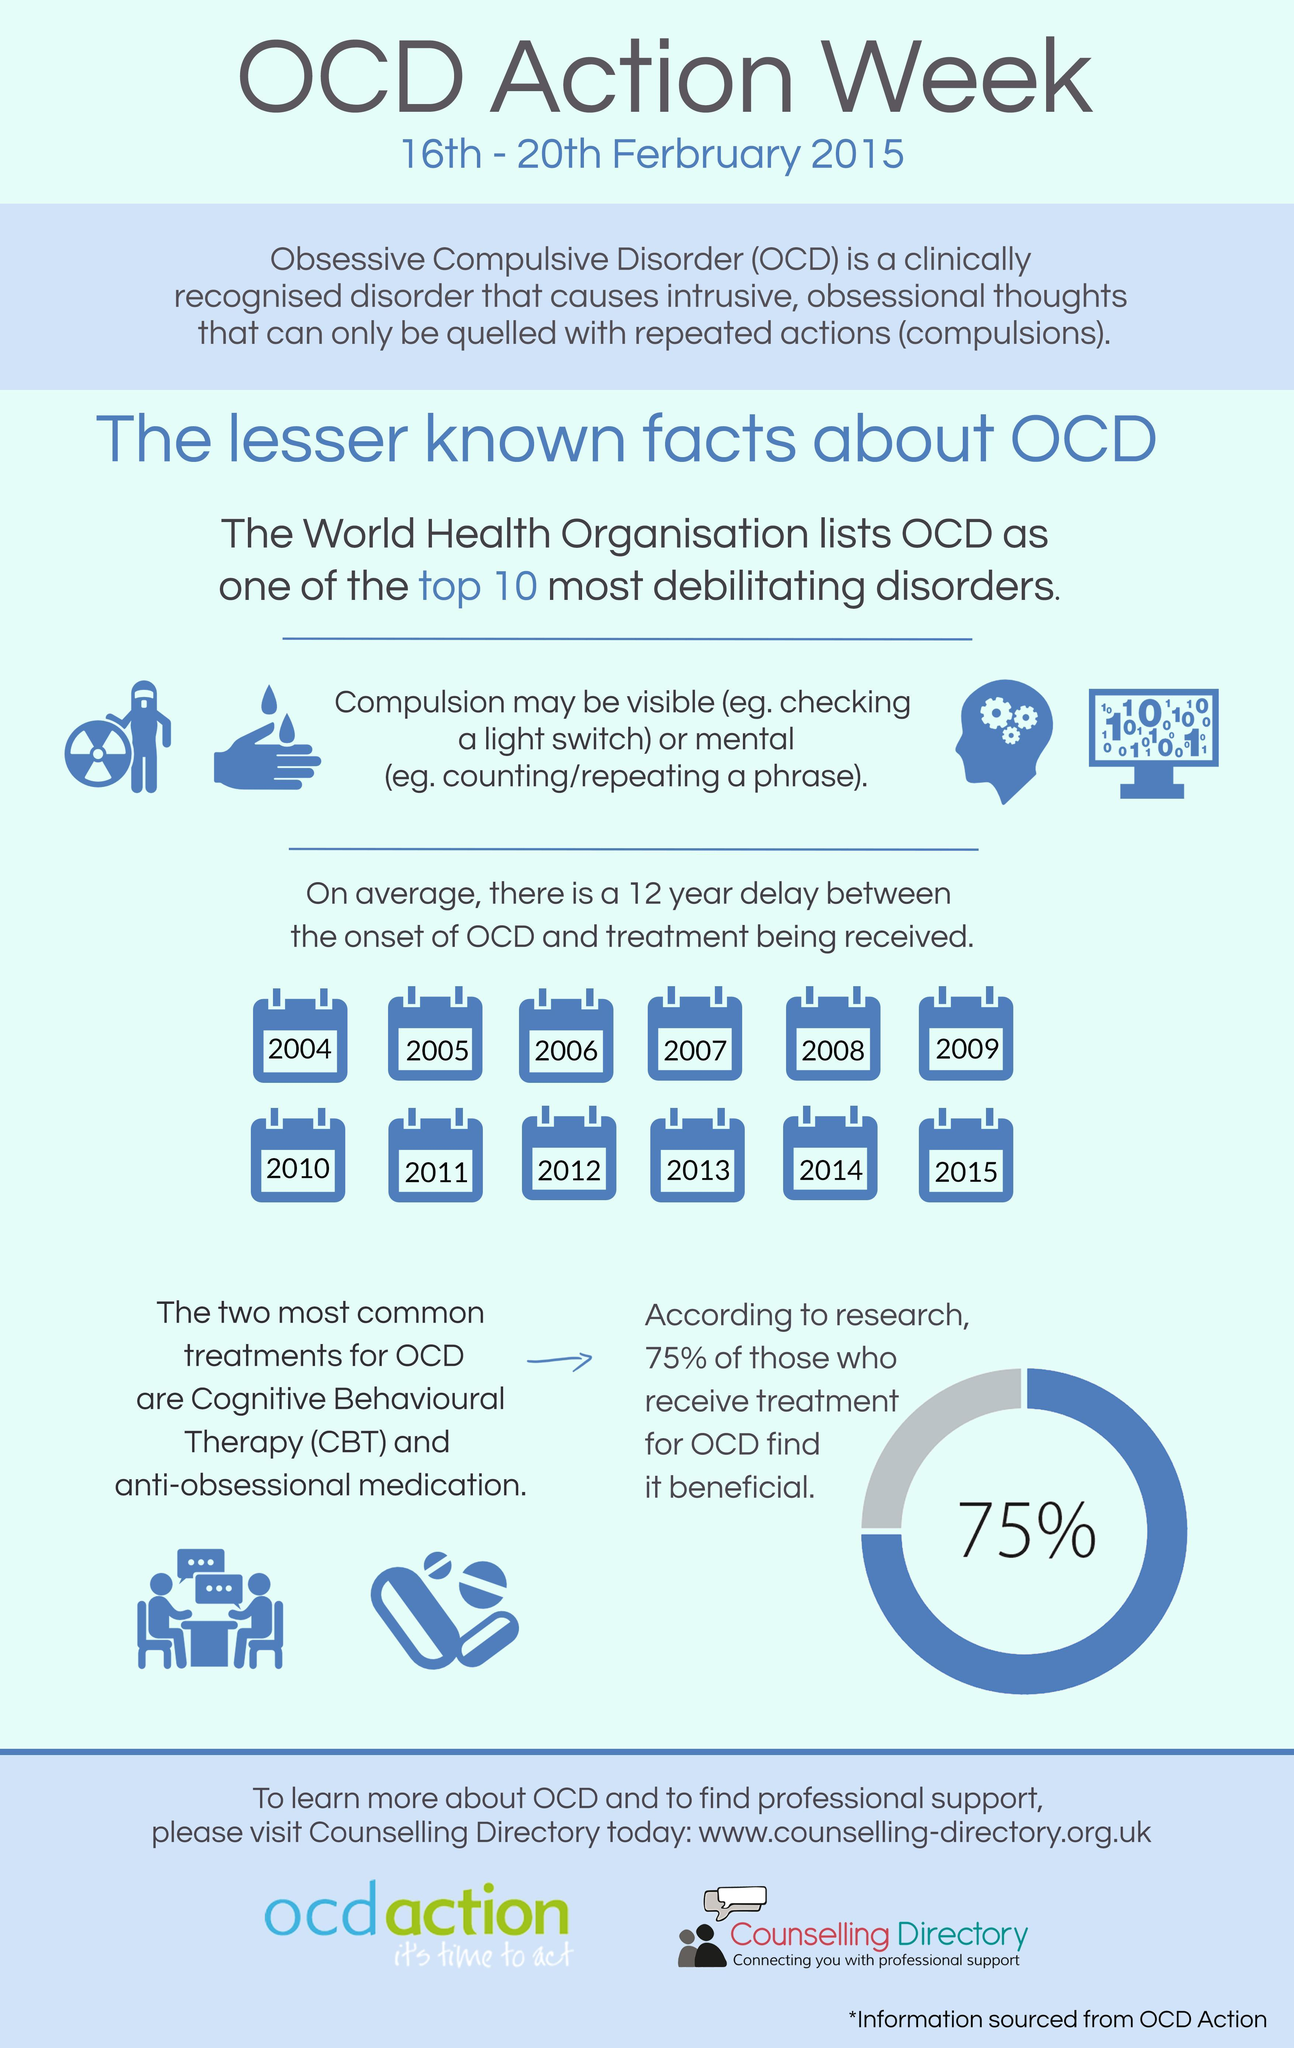For what percentage of people has OCD treatment been helpful?
Answer the question with a short phrase. 75% What are the treatment methods for Obsessive Compulsive Disorder? Cognitive Behavioural Therapy (CBT) and anti-obsessional medication In what percent of people treatment for OCD has not been beneficial? 25% 